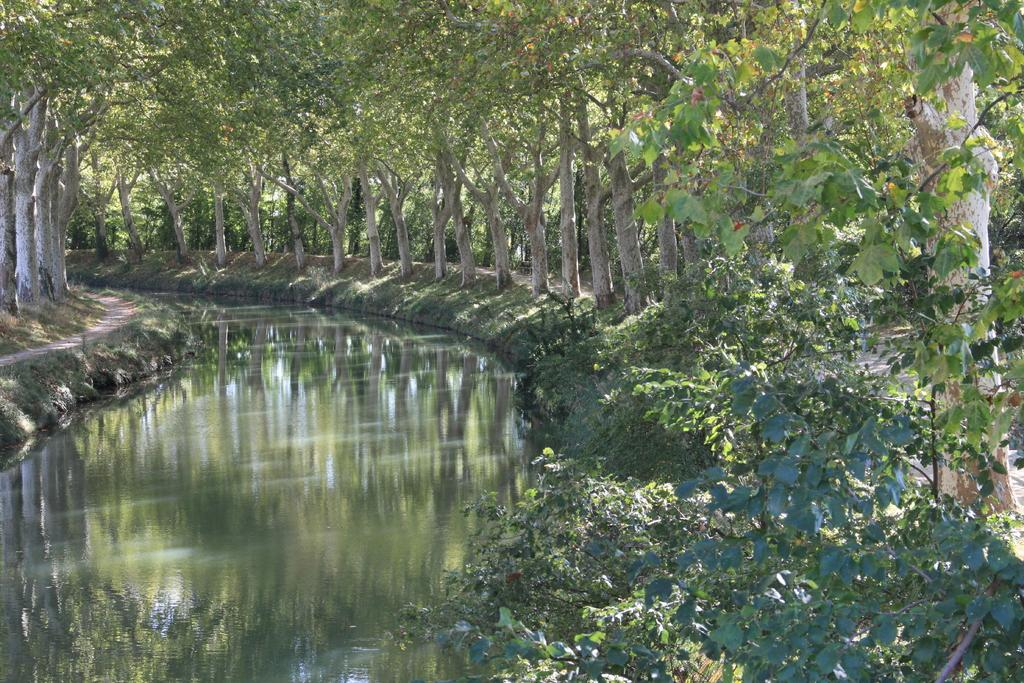What type of vegetation is present in the image? There are green color trees in the image. What natural element can be seen alongside the trees? There is water visible in the image. What is the amount of stem cells present in the image? There is no mention of stem cells in the image, as it features green color trees and water. 